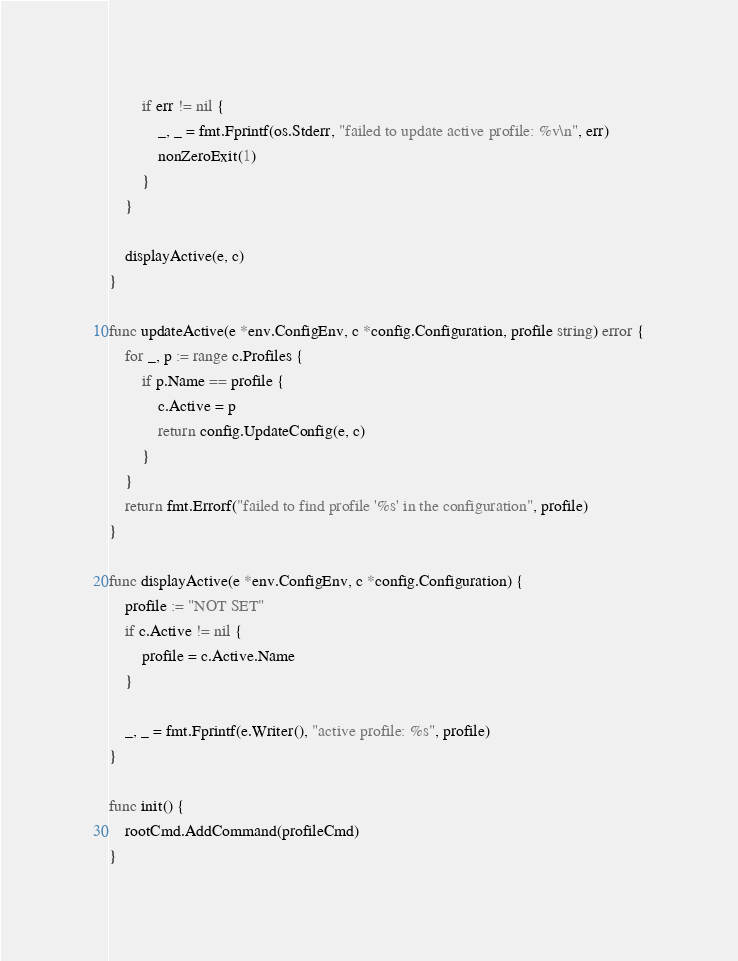Convert code to text. <code><loc_0><loc_0><loc_500><loc_500><_Go_>		if err != nil {
			_, _ = fmt.Fprintf(os.Stderr, "failed to update active profile: %v\n", err)
			nonZeroExit(1)
		}
	}

	displayActive(e, c)
}

func updateActive(e *env.ConfigEnv, c *config.Configuration, profile string) error {
	for _, p := range c.Profiles {
		if p.Name == profile {
			c.Active = p
			return config.UpdateConfig(e, c)
		}
	}
	return fmt.Errorf("failed to find profile '%s' in the configuration", profile)
}

func displayActive(e *env.ConfigEnv, c *config.Configuration) {
	profile := "NOT SET"
	if c.Active != nil {
		profile = c.Active.Name
	}

	_, _ = fmt.Fprintf(e.Writer(), "active profile: %s", profile)
}

func init() {
	rootCmd.AddCommand(profileCmd)
}
</code> 